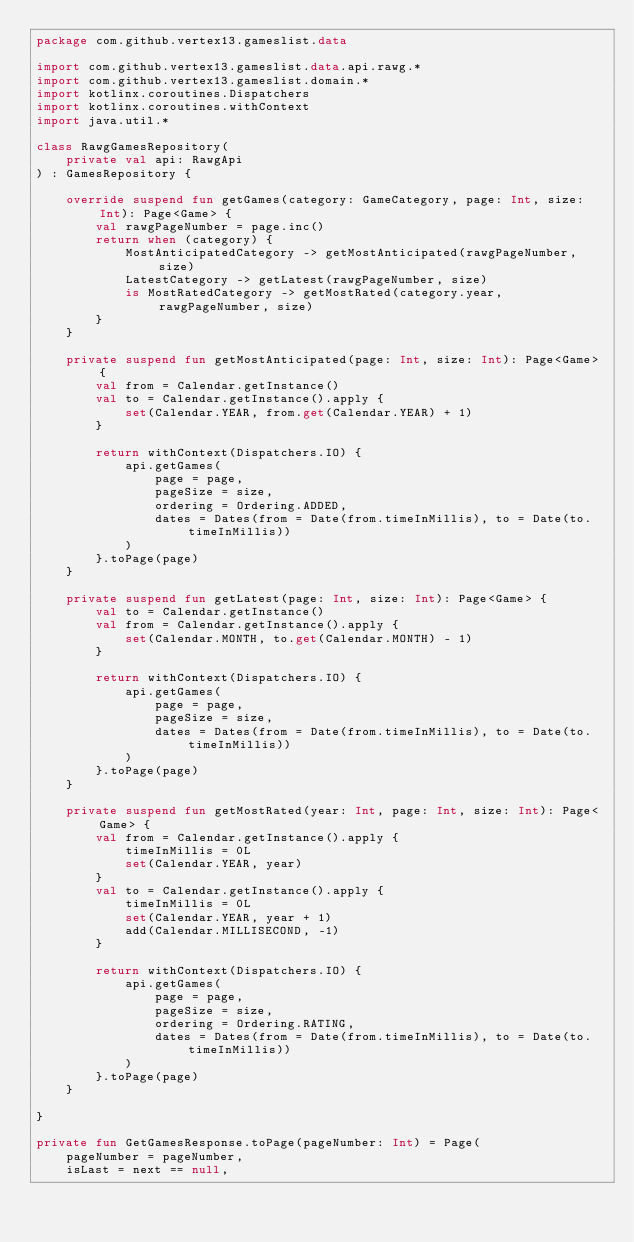Convert code to text. <code><loc_0><loc_0><loc_500><loc_500><_Kotlin_>package com.github.vertex13.gameslist.data

import com.github.vertex13.gameslist.data.api.rawg.*
import com.github.vertex13.gameslist.domain.*
import kotlinx.coroutines.Dispatchers
import kotlinx.coroutines.withContext
import java.util.*

class RawgGamesRepository(
    private val api: RawgApi
) : GamesRepository {

    override suspend fun getGames(category: GameCategory, page: Int, size: Int): Page<Game> {
        val rawgPageNumber = page.inc()
        return when (category) {
            MostAnticipatedCategory -> getMostAnticipated(rawgPageNumber, size)
            LatestCategory -> getLatest(rawgPageNumber, size)
            is MostRatedCategory -> getMostRated(category.year, rawgPageNumber, size)
        }
    }

    private suspend fun getMostAnticipated(page: Int, size: Int): Page<Game> {
        val from = Calendar.getInstance()
        val to = Calendar.getInstance().apply {
            set(Calendar.YEAR, from.get(Calendar.YEAR) + 1)
        }

        return withContext(Dispatchers.IO) {
            api.getGames(
                page = page,
                pageSize = size,
                ordering = Ordering.ADDED,
                dates = Dates(from = Date(from.timeInMillis), to = Date(to.timeInMillis))
            )
        }.toPage(page)
    }

    private suspend fun getLatest(page: Int, size: Int): Page<Game> {
        val to = Calendar.getInstance()
        val from = Calendar.getInstance().apply {
            set(Calendar.MONTH, to.get(Calendar.MONTH) - 1)
        }

        return withContext(Dispatchers.IO) {
            api.getGames(
                page = page,
                pageSize = size,
                dates = Dates(from = Date(from.timeInMillis), to = Date(to.timeInMillis))
            )
        }.toPage(page)
    }

    private suspend fun getMostRated(year: Int, page: Int, size: Int): Page<Game> {
        val from = Calendar.getInstance().apply {
            timeInMillis = 0L
            set(Calendar.YEAR, year)
        }
        val to = Calendar.getInstance().apply {
            timeInMillis = 0L
            set(Calendar.YEAR, year + 1)
            add(Calendar.MILLISECOND, -1)
        }

        return withContext(Dispatchers.IO) {
            api.getGames(
                page = page,
                pageSize = size,
                ordering = Ordering.RATING,
                dates = Dates(from = Date(from.timeInMillis), to = Date(to.timeInMillis))
            )
        }.toPage(page)
    }

}

private fun GetGamesResponse.toPage(pageNumber: Int) = Page(
    pageNumber = pageNumber,
    isLast = next == null,</code> 